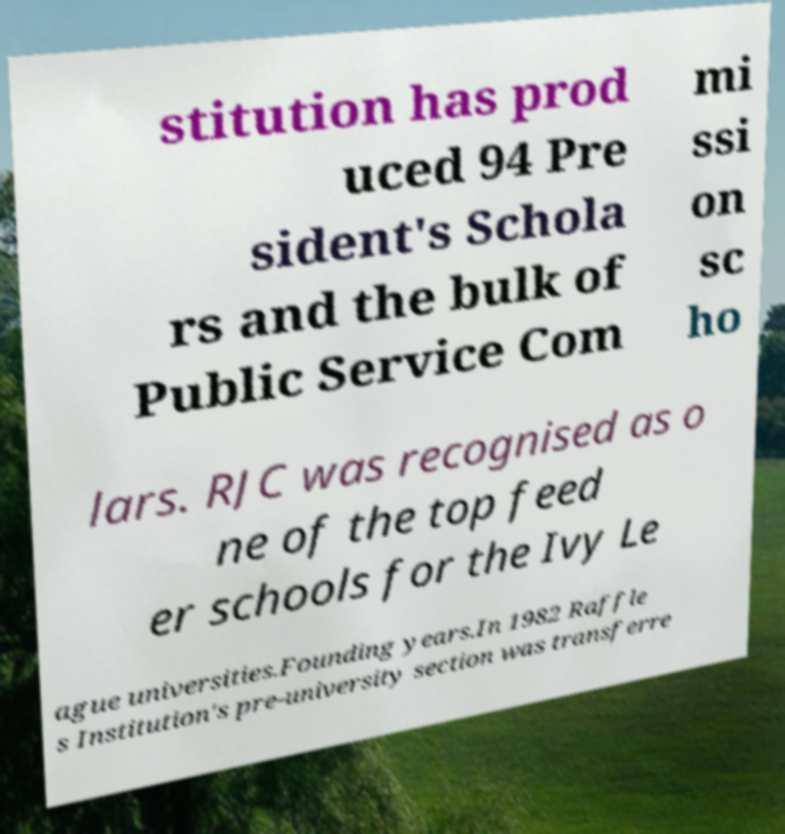What messages or text are displayed in this image? I need them in a readable, typed format. stitution has prod uced 94 Pre sident's Schola rs and the bulk of Public Service Com mi ssi on sc ho lars. RJC was recognised as o ne of the top feed er schools for the Ivy Le ague universities.Founding years.In 1982 Raffle s Institution's pre-university section was transferre 